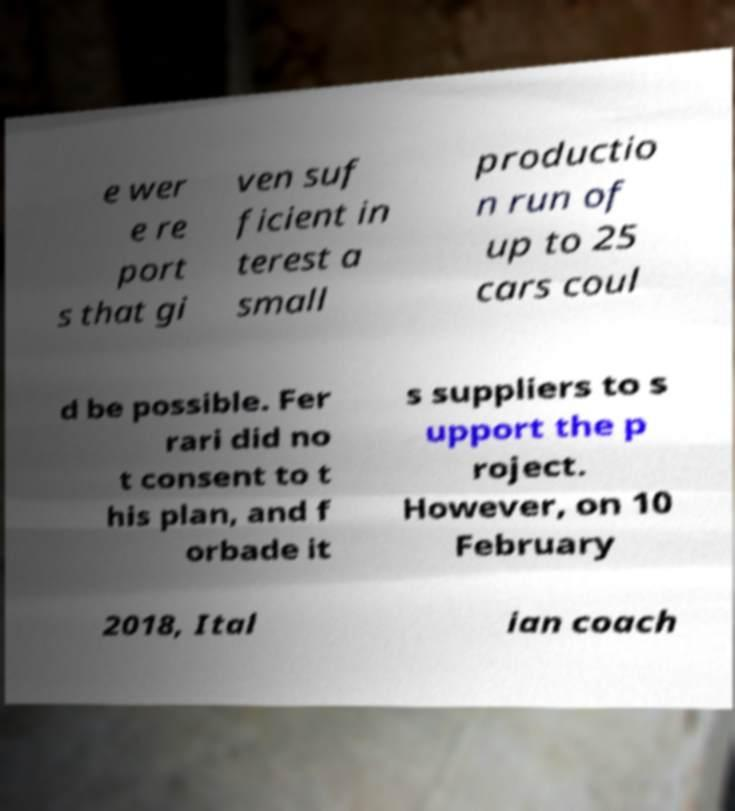Can you accurately transcribe the text from the provided image for me? e wer e re port s that gi ven suf ficient in terest a small productio n run of up to 25 cars coul d be possible. Fer rari did no t consent to t his plan, and f orbade it s suppliers to s upport the p roject. However, on 10 February 2018, Ital ian coach 